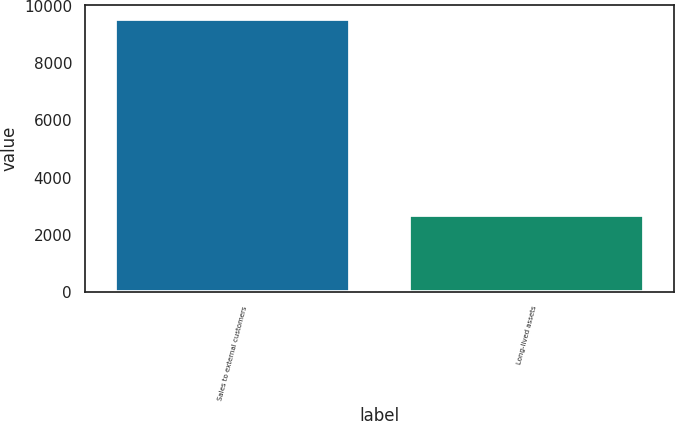<chart> <loc_0><loc_0><loc_500><loc_500><bar_chart><fcel>Sales to external customers<fcel>Long-lived assets<nl><fcel>9544<fcel>2698<nl></chart> 